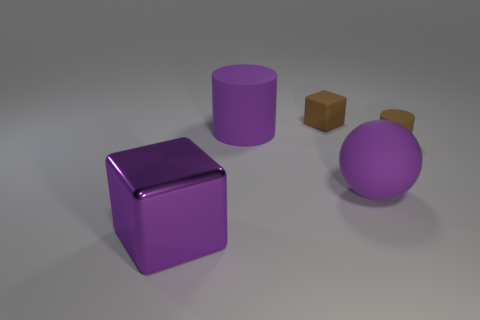The large cylinder that is the same material as the sphere is what color? The large cylinder shares its material with the sphere and both display a glossy purple hue, which gives them a vibrant and reflective appearance. 